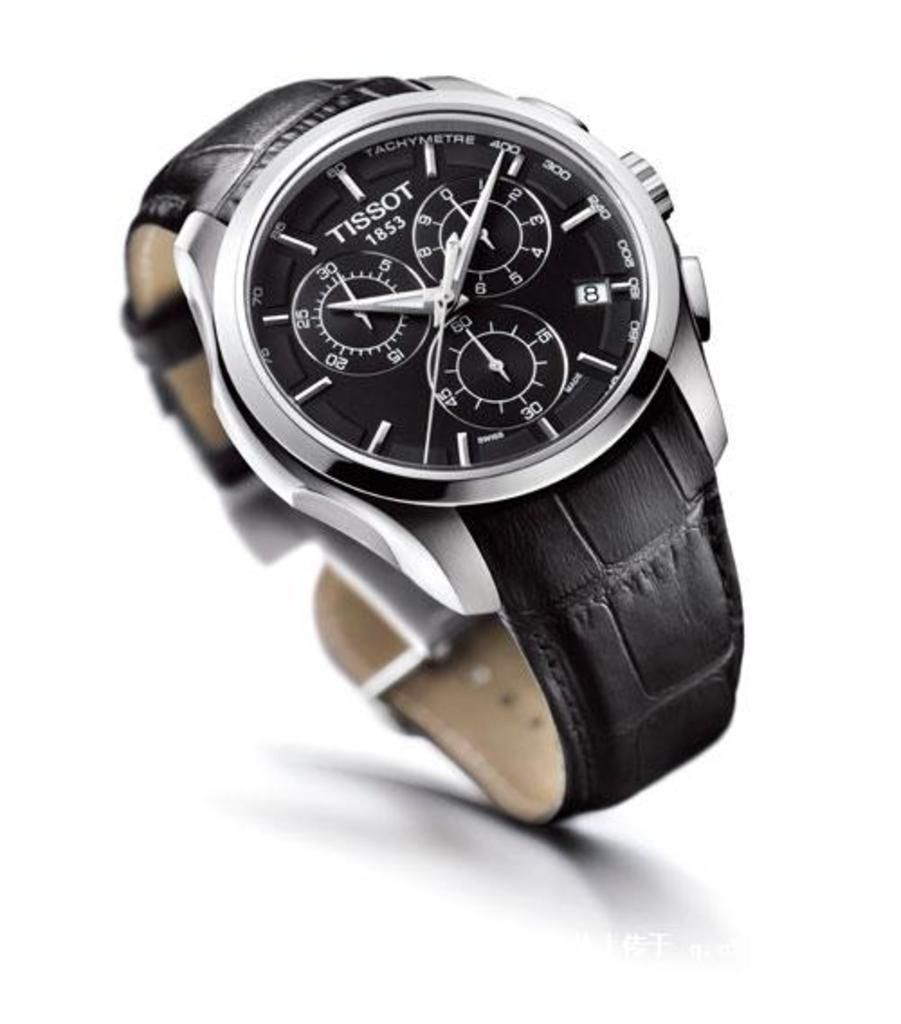<image>
Relay a brief, clear account of the picture shown. A Tissot watch with a black band and a black face. 